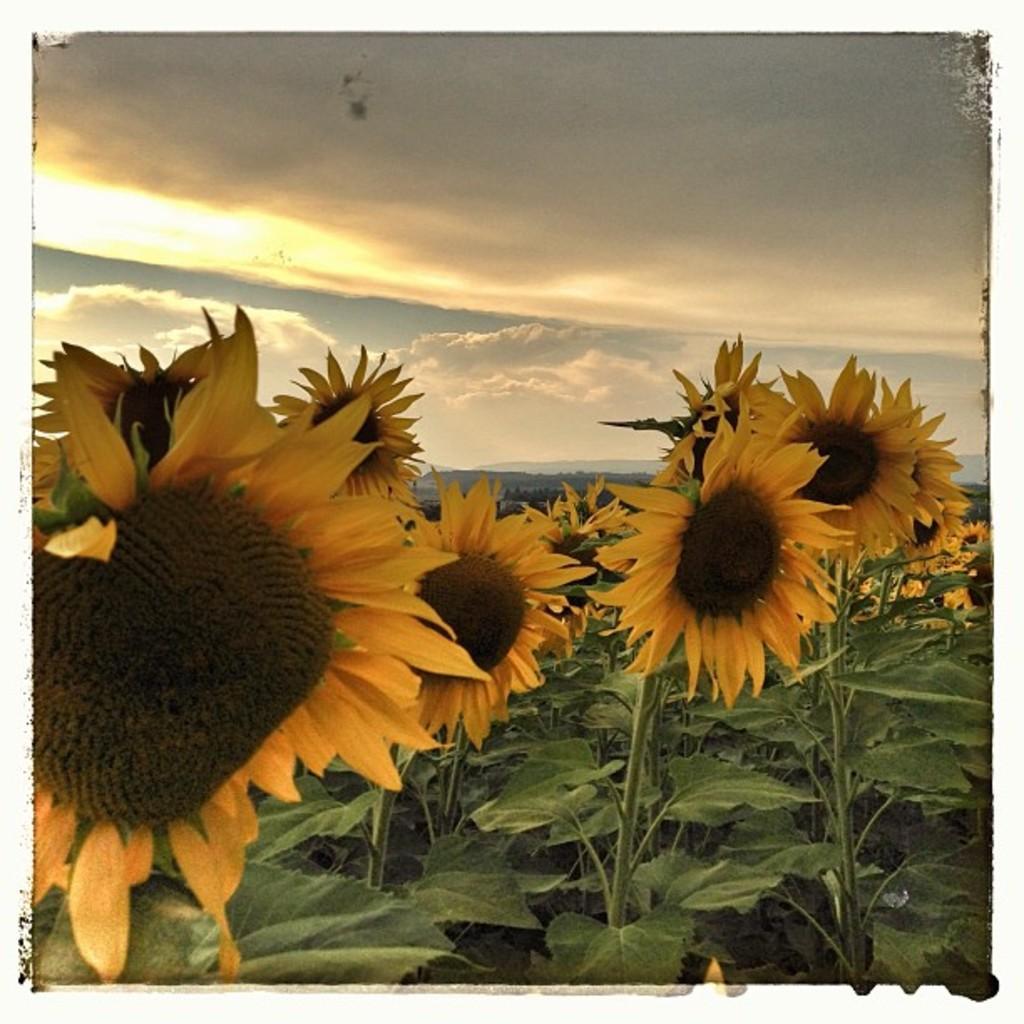Could you give a brief overview of what you see in this image? In this image we can see there are plants with flowers, and the sky in the background. 